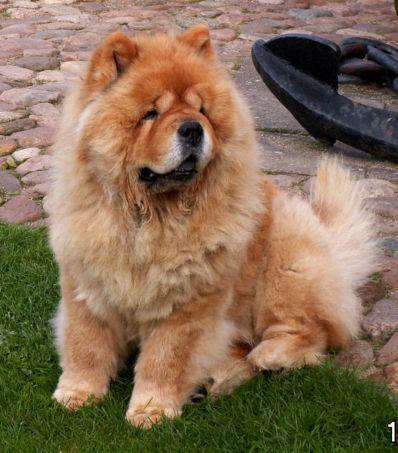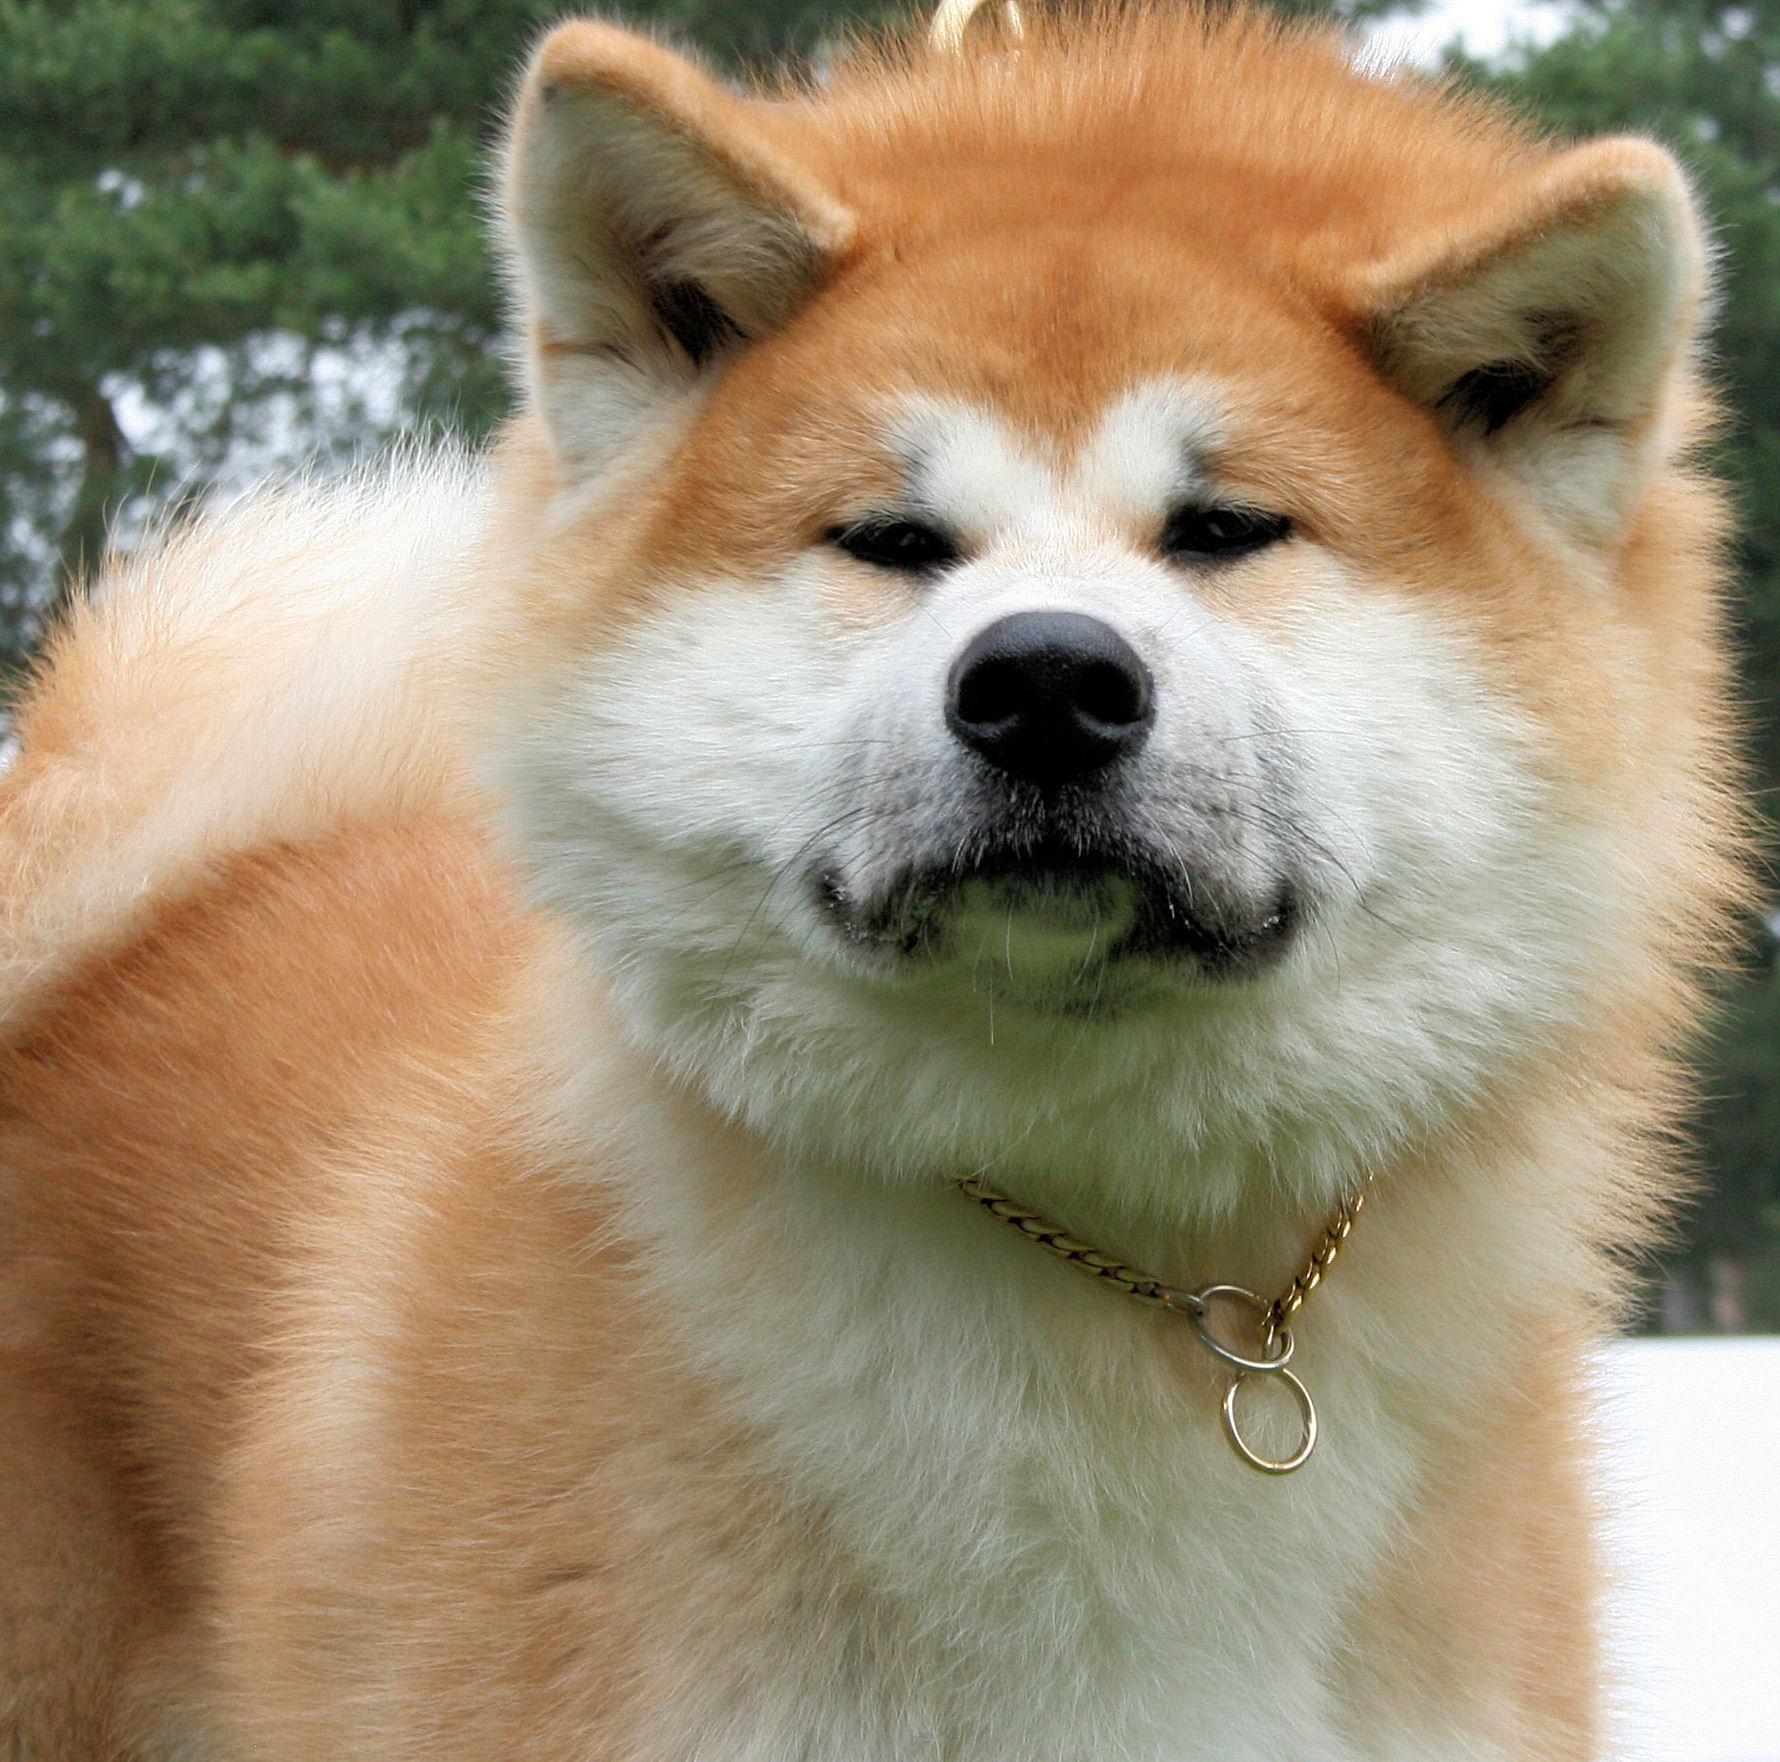The first image is the image on the left, the second image is the image on the right. Examine the images to the left and right. Is the description "Some type of small toy is next to a fluffy dog in one image." accurate? Answer yes or no. No. 